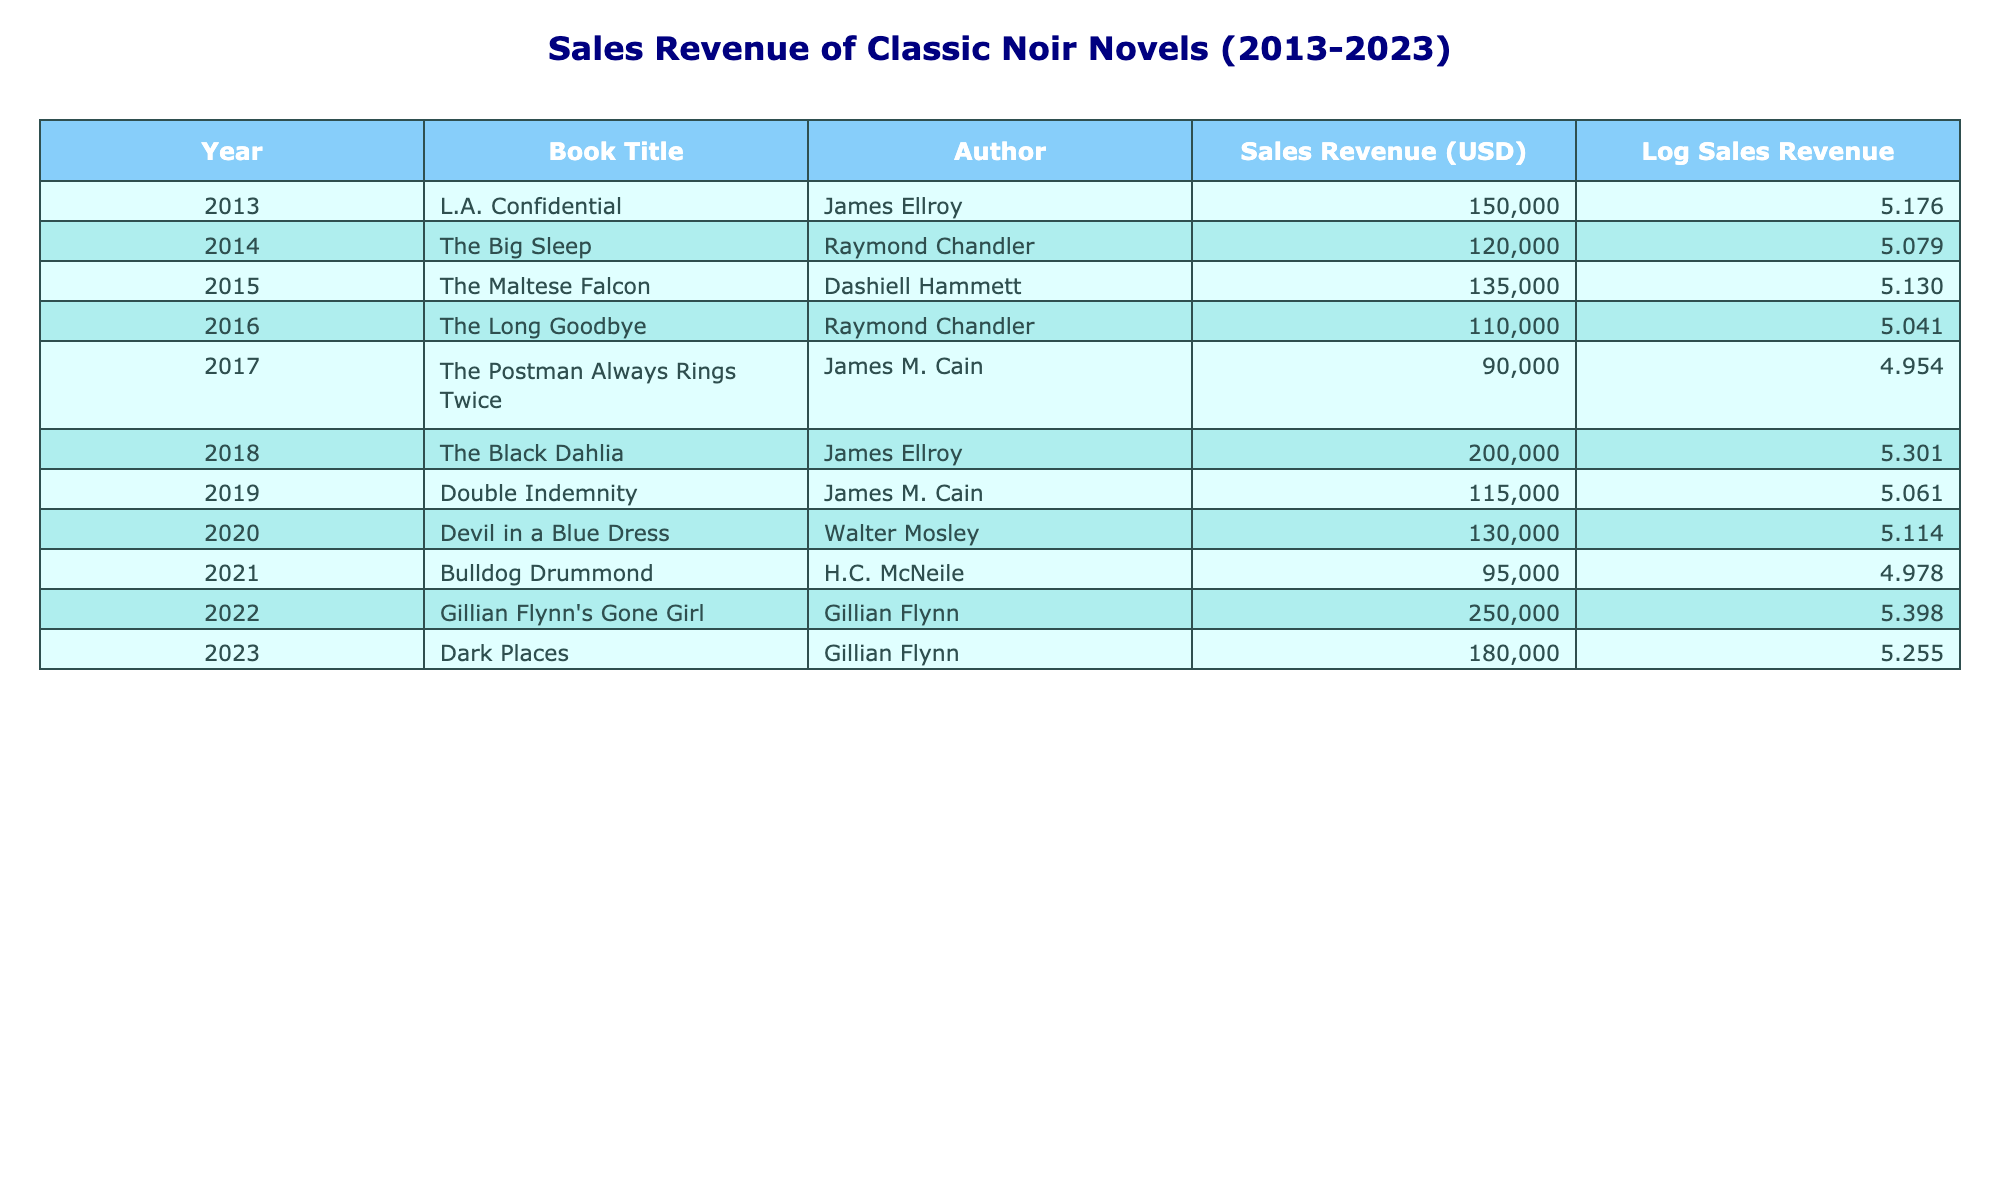What was the sales revenue for "The Black Dahlia"? The table lists "The Black Dahlia" with a sales revenue of 200,000 USD for the year 2018.
Answer: 200,000 USD Which book had the highest sales revenue, and what was that amount? Reviewing the table, "Gillian Flynn's Gone Girl" had the highest sales revenue of 250,000 USD in 2022.
Answer: "Gillian Flynn's Gone Girl" with 250,000 USD How many novels had sales revenue above 150,000 USD? By counting the entries in the table, there are four novels: "L.A. Confidential," "The Black Dahlia," "Gillian Flynn's Gone Girl," and "Dark Places," which all exceeded 150,000 USD in sales.
Answer: Four novels What is the average sales revenue of the novels listed in the table? The total sales revenue sums to 1,340,000 USD (150,000 + 120,000 + 135,000 + 110,000 + 90,000 + 200,000 + 115,000 + 130,000 + 95,000 + 250,000 + 180,000). There are 11 books, so the average is 1,340,000 / 11 = 121,818.18 USD, approximately 121,818 USD.
Answer: 121,818 USD Did "The Long Goodbye" have a higher sales revenue than "Double Indemnity"? "The Long Goodbye" had 110,000 USD in sales, while "Double Indemnity" had 115,000 USD; therefore, "The Long Goodbye" had a lower sales revenue.
Answer: No What was the difference in sales revenue between the highest and the lowest sold novels? "Gillian Flynn's Gone Girl" sold 250,000 USD, and "The Postman Always Rings Twice" sold 90,000 USD. The difference is 250,000 - 90,000 = 160,000 USD.
Answer: 160,000 USD Which author had the most novels listed in the table, and how many were there? James Ellroy is represented by two novels: "L.A. Confidential" and "The Black Dahlia." No other author has more than one entry in this selection.
Answer: James Ellroy, 2 novels What was the logarithmic sales revenue for "Devil in a Blue Dress"? The sales revenue of "Devil in a Blue Dress" is 130,000 USD; applying the logarithmic transformation, log10(130,000) gives approximately 5.113.
Answer: Approximately 5.113 